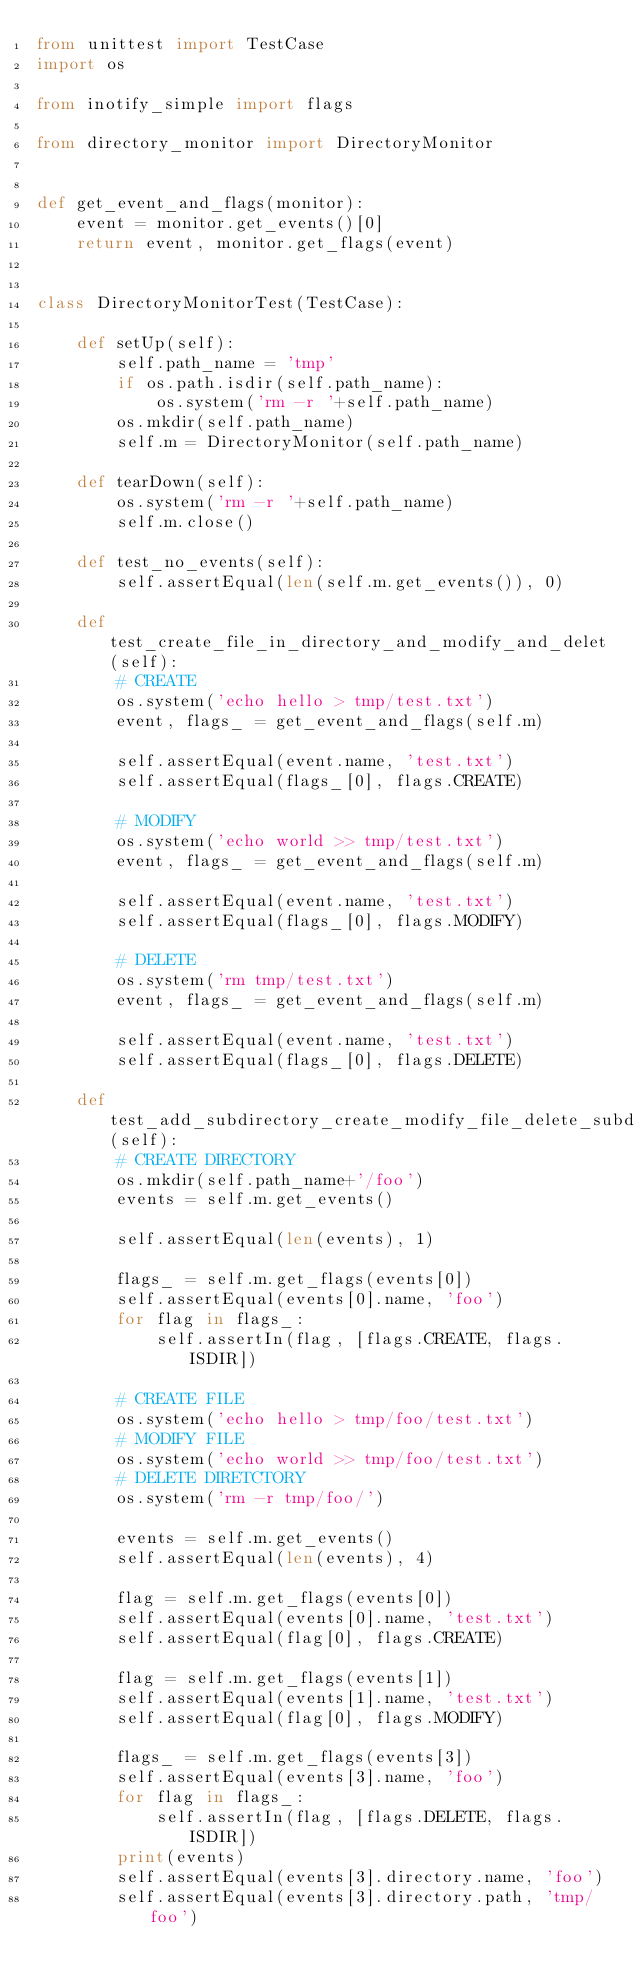Convert code to text. <code><loc_0><loc_0><loc_500><loc_500><_Python_>from unittest import TestCase
import os

from inotify_simple import flags

from directory_monitor import DirectoryMonitor


def get_event_and_flags(monitor):
    event = monitor.get_events()[0]
    return event, monitor.get_flags(event)


class DirectoryMonitorTest(TestCase):

    def setUp(self):
        self.path_name = 'tmp'
        if os.path.isdir(self.path_name):
            os.system('rm -r '+self.path_name)
        os.mkdir(self.path_name)
        self.m = DirectoryMonitor(self.path_name)

    def tearDown(self):
        os.system('rm -r '+self.path_name)
        self.m.close()

    def test_no_events(self):
        self.assertEqual(len(self.m.get_events()), 0)

    def test_create_file_in_directory_and_modify_and_delet(self):
        # CREATE
        os.system('echo hello > tmp/test.txt')
        event, flags_ = get_event_and_flags(self.m)

        self.assertEqual(event.name, 'test.txt')
        self.assertEqual(flags_[0], flags.CREATE)

        # MODIFY
        os.system('echo world >> tmp/test.txt')
        event, flags_ = get_event_and_flags(self.m)

        self.assertEqual(event.name, 'test.txt')
        self.assertEqual(flags_[0], flags.MODIFY)

        # DELETE
        os.system('rm tmp/test.txt')
        event, flags_ = get_event_and_flags(self.m)

        self.assertEqual(event.name, 'test.txt')
        self.assertEqual(flags_[0], flags.DELETE)

    def test_add_subdirectory_create_modify_file_delete_subdirectory(self):
        # CREATE DIRECTORY
        os.mkdir(self.path_name+'/foo')
        events = self.m.get_events()

        self.assertEqual(len(events), 1)

        flags_ = self.m.get_flags(events[0])
        self.assertEqual(events[0].name, 'foo')
        for flag in flags_:
            self.assertIn(flag, [flags.CREATE, flags.ISDIR])

        # CREATE FILE
        os.system('echo hello > tmp/foo/test.txt')
        # MODIFY FILE
        os.system('echo world >> tmp/foo/test.txt')
        # DELETE DIRETCTORY
        os.system('rm -r tmp/foo/')

        events = self.m.get_events()
        self.assertEqual(len(events), 4)

        flag = self.m.get_flags(events[0])
        self.assertEqual(events[0].name, 'test.txt')
        self.assertEqual(flag[0], flags.CREATE)

        flag = self.m.get_flags(events[1])
        self.assertEqual(events[1].name, 'test.txt')
        self.assertEqual(flag[0], flags.MODIFY)

        flags_ = self.m.get_flags(events[3])
        self.assertEqual(events[3].name, 'foo')
        for flag in flags_:
            self.assertIn(flag, [flags.DELETE, flags.ISDIR])
        print(events)
        self.assertEqual(events[3].directory.name, 'foo')
        self.assertEqual(events[3].directory.path, 'tmp/foo')
</code> 